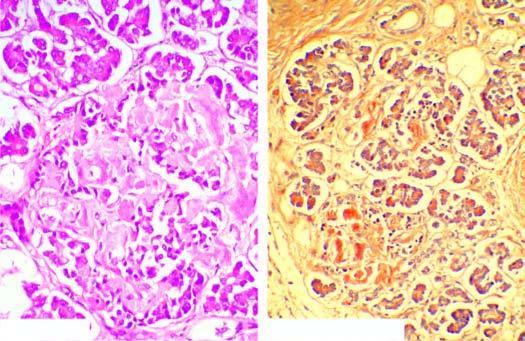re the islets mostly replaced by structureless eosinophilic material which stains positively with congo red?
Answer the question using a single word or phrase. Yes 